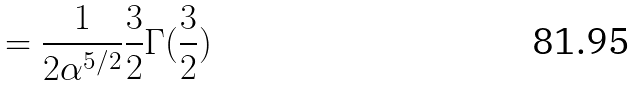<formula> <loc_0><loc_0><loc_500><loc_500>= \frac { 1 } { 2 \alpha ^ { 5 / 2 } } \frac { 3 } { 2 } \Gamma ( \frac { 3 } { 2 } )</formula> 